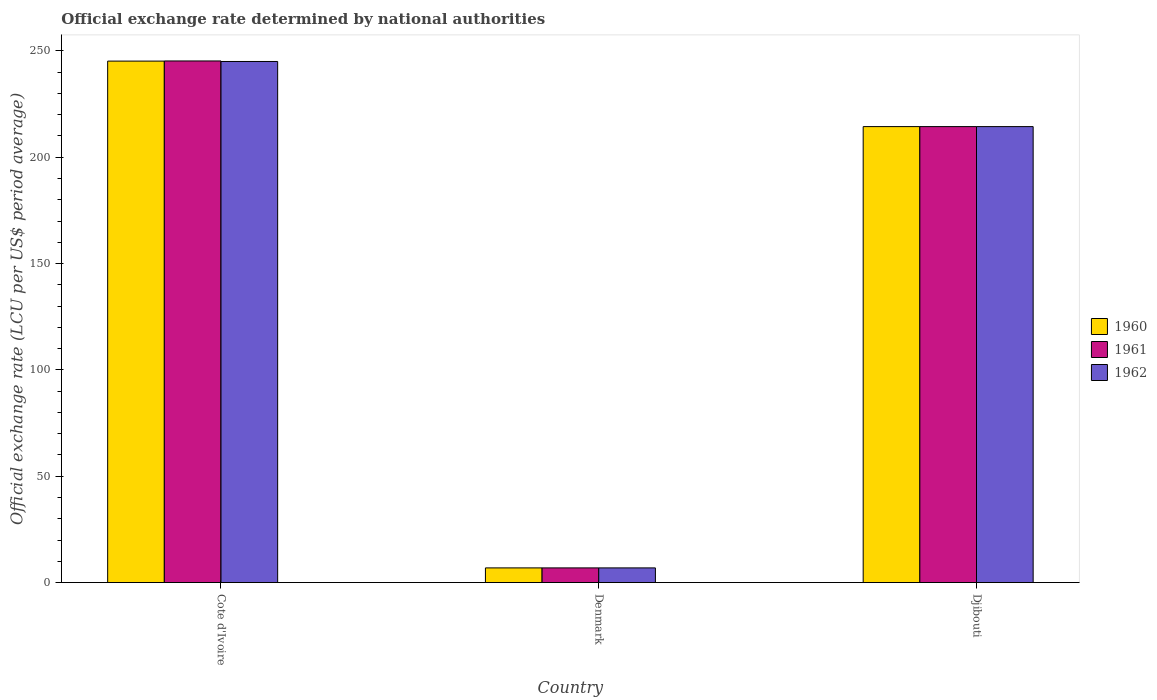How many different coloured bars are there?
Keep it short and to the point. 3. How many groups of bars are there?
Ensure brevity in your answer.  3. Are the number of bars per tick equal to the number of legend labels?
Give a very brief answer. Yes. Are the number of bars on each tick of the X-axis equal?
Offer a terse response. Yes. What is the label of the 3rd group of bars from the left?
Provide a succinct answer. Djibouti. In how many cases, is the number of bars for a given country not equal to the number of legend labels?
Your answer should be compact. 0. What is the official exchange rate in 1962 in Denmark?
Your answer should be compact. 6.91. Across all countries, what is the maximum official exchange rate in 1961?
Give a very brief answer. 245.26. Across all countries, what is the minimum official exchange rate in 1960?
Your answer should be very brief. 6.91. In which country was the official exchange rate in 1962 maximum?
Give a very brief answer. Cote d'Ivoire. What is the total official exchange rate in 1960 in the graph?
Provide a short and direct response. 466.49. What is the difference between the official exchange rate in 1960 in Cote d'Ivoire and that in Djibouti?
Your answer should be very brief. 30.8. What is the difference between the official exchange rate in 1961 in Djibouti and the official exchange rate in 1960 in Denmark?
Offer a terse response. 207.48. What is the average official exchange rate in 1960 per country?
Give a very brief answer. 155.5. What is the difference between the official exchange rate of/in 1960 and official exchange rate of/in 1961 in Djibouti?
Offer a terse response. 0. In how many countries, is the official exchange rate in 1961 greater than 130 LCU?
Provide a short and direct response. 2. What is the ratio of the official exchange rate in 1962 in Cote d'Ivoire to that in Djibouti?
Give a very brief answer. 1.14. What is the difference between the highest and the second highest official exchange rate in 1960?
Your response must be concise. 30.8. What is the difference between the highest and the lowest official exchange rate in 1960?
Ensure brevity in your answer.  238.29. Is the sum of the official exchange rate in 1960 in Denmark and Djibouti greater than the maximum official exchange rate in 1962 across all countries?
Make the answer very short. No. What does the 1st bar from the right in Djibouti represents?
Offer a very short reply. 1962. How many bars are there?
Your response must be concise. 9. What is the difference between two consecutive major ticks on the Y-axis?
Ensure brevity in your answer.  50. Does the graph contain any zero values?
Ensure brevity in your answer.  No. Where does the legend appear in the graph?
Keep it short and to the point. Center right. What is the title of the graph?
Provide a succinct answer. Official exchange rate determined by national authorities. What is the label or title of the Y-axis?
Provide a short and direct response. Official exchange rate (LCU per US$ period average). What is the Official exchange rate (LCU per US$ period average) of 1960 in Cote d'Ivoire?
Your answer should be compact. 245.2. What is the Official exchange rate (LCU per US$ period average) of 1961 in Cote d'Ivoire?
Make the answer very short. 245.26. What is the Official exchange rate (LCU per US$ period average) in 1962 in Cote d'Ivoire?
Offer a terse response. 245.01. What is the Official exchange rate (LCU per US$ period average) of 1960 in Denmark?
Keep it short and to the point. 6.91. What is the Official exchange rate (LCU per US$ period average) in 1961 in Denmark?
Ensure brevity in your answer.  6.91. What is the Official exchange rate (LCU per US$ period average) in 1962 in Denmark?
Your answer should be compact. 6.91. What is the Official exchange rate (LCU per US$ period average) of 1960 in Djibouti?
Give a very brief answer. 214.39. What is the Official exchange rate (LCU per US$ period average) in 1961 in Djibouti?
Your response must be concise. 214.39. What is the Official exchange rate (LCU per US$ period average) of 1962 in Djibouti?
Provide a short and direct response. 214.39. Across all countries, what is the maximum Official exchange rate (LCU per US$ period average) of 1960?
Make the answer very short. 245.2. Across all countries, what is the maximum Official exchange rate (LCU per US$ period average) of 1961?
Offer a very short reply. 245.26. Across all countries, what is the maximum Official exchange rate (LCU per US$ period average) of 1962?
Provide a short and direct response. 245.01. Across all countries, what is the minimum Official exchange rate (LCU per US$ period average) in 1960?
Offer a very short reply. 6.91. Across all countries, what is the minimum Official exchange rate (LCU per US$ period average) of 1961?
Provide a succinct answer. 6.91. Across all countries, what is the minimum Official exchange rate (LCU per US$ period average) in 1962?
Your answer should be compact. 6.91. What is the total Official exchange rate (LCU per US$ period average) of 1960 in the graph?
Make the answer very short. 466.49. What is the total Official exchange rate (LCU per US$ period average) in 1961 in the graph?
Provide a succinct answer. 466.56. What is the total Official exchange rate (LCU per US$ period average) of 1962 in the graph?
Provide a succinct answer. 466.31. What is the difference between the Official exchange rate (LCU per US$ period average) of 1960 in Cote d'Ivoire and that in Denmark?
Your response must be concise. 238.29. What is the difference between the Official exchange rate (LCU per US$ period average) of 1961 in Cote d'Ivoire and that in Denmark?
Your answer should be compact. 238.35. What is the difference between the Official exchange rate (LCU per US$ period average) of 1962 in Cote d'Ivoire and that in Denmark?
Your response must be concise. 238.11. What is the difference between the Official exchange rate (LCU per US$ period average) of 1960 in Cote d'Ivoire and that in Djibouti?
Give a very brief answer. 30.8. What is the difference between the Official exchange rate (LCU per US$ period average) of 1961 in Cote d'Ivoire and that in Djibouti?
Give a very brief answer. 30.87. What is the difference between the Official exchange rate (LCU per US$ period average) in 1962 in Cote d'Ivoire and that in Djibouti?
Give a very brief answer. 30.62. What is the difference between the Official exchange rate (LCU per US$ period average) of 1960 in Denmark and that in Djibouti?
Keep it short and to the point. -207.48. What is the difference between the Official exchange rate (LCU per US$ period average) of 1961 in Denmark and that in Djibouti?
Ensure brevity in your answer.  -207.48. What is the difference between the Official exchange rate (LCU per US$ period average) of 1962 in Denmark and that in Djibouti?
Your response must be concise. -207.48. What is the difference between the Official exchange rate (LCU per US$ period average) of 1960 in Cote d'Ivoire and the Official exchange rate (LCU per US$ period average) of 1961 in Denmark?
Make the answer very short. 238.29. What is the difference between the Official exchange rate (LCU per US$ period average) in 1960 in Cote d'Ivoire and the Official exchange rate (LCU per US$ period average) in 1962 in Denmark?
Keep it short and to the point. 238.29. What is the difference between the Official exchange rate (LCU per US$ period average) of 1961 in Cote d'Ivoire and the Official exchange rate (LCU per US$ period average) of 1962 in Denmark?
Ensure brevity in your answer.  238.35. What is the difference between the Official exchange rate (LCU per US$ period average) of 1960 in Cote d'Ivoire and the Official exchange rate (LCU per US$ period average) of 1961 in Djibouti?
Offer a very short reply. 30.8. What is the difference between the Official exchange rate (LCU per US$ period average) of 1960 in Cote d'Ivoire and the Official exchange rate (LCU per US$ period average) of 1962 in Djibouti?
Give a very brief answer. 30.8. What is the difference between the Official exchange rate (LCU per US$ period average) in 1961 in Cote d'Ivoire and the Official exchange rate (LCU per US$ period average) in 1962 in Djibouti?
Make the answer very short. 30.87. What is the difference between the Official exchange rate (LCU per US$ period average) of 1960 in Denmark and the Official exchange rate (LCU per US$ period average) of 1961 in Djibouti?
Ensure brevity in your answer.  -207.48. What is the difference between the Official exchange rate (LCU per US$ period average) in 1960 in Denmark and the Official exchange rate (LCU per US$ period average) in 1962 in Djibouti?
Offer a very short reply. -207.48. What is the difference between the Official exchange rate (LCU per US$ period average) in 1961 in Denmark and the Official exchange rate (LCU per US$ period average) in 1962 in Djibouti?
Your response must be concise. -207.48. What is the average Official exchange rate (LCU per US$ period average) of 1960 per country?
Your answer should be very brief. 155.5. What is the average Official exchange rate (LCU per US$ period average) of 1961 per country?
Ensure brevity in your answer.  155.52. What is the average Official exchange rate (LCU per US$ period average) of 1962 per country?
Provide a succinct answer. 155.44. What is the difference between the Official exchange rate (LCU per US$ period average) in 1960 and Official exchange rate (LCU per US$ period average) in 1961 in Cote d'Ivoire?
Ensure brevity in your answer.  -0.07. What is the difference between the Official exchange rate (LCU per US$ period average) of 1960 and Official exchange rate (LCU per US$ period average) of 1962 in Cote d'Ivoire?
Provide a succinct answer. 0.18. What is the difference between the Official exchange rate (LCU per US$ period average) in 1961 and Official exchange rate (LCU per US$ period average) in 1962 in Cote d'Ivoire?
Your answer should be compact. 0.25. What is the difference between the Official exchange rate (LCU per US$ period average) in 1960 and Official exchange rate (LCU per US$ period average) in 1962 in Denmark?
Ensure brevity in your answer.  0. What is the ratio of the Official exchange rate (LCU per US$ period average) in 1960 in Cote d'Ivoire to that in Denmark?
Offer a very short reply. 35.5. What is the ratio of the Official exchange rate (LCU per US$ period average) in 1961 in Cote d'Ivoire to that in Denmark?
Your answer should be very brief. 35.51. What is the ratio of the Official exchange rate (LCU per US$ period average) of 1962 in Cote d'Ivoire to that in Denmark?
Your answer should be compact. 35.47. What is the ratio of the Official exchange rate (LCU per US$ period average) of 1960 in Cote d'Ivoire to that in Djibouti?
Keep it short and to the point. 1.14. What is the ratio of the Official exchange rate (LCU per US$ period average) in 1961 in Cote d'Ivoire to that in Djibouti?
Provide a short and direct response. 1.14. What is the ratio of the Official exchange rate (LCU per US$ period average) of 1962 in Cote d'Ivoire to that in Djibouti?
Your answer should be compact. 1.14. What is the ratio of the Official exchange rate (LCU per US$ period average) in 1960 in Denmark to that in Djibouti?
Ensure brevity in your answer.  0.03. What is the ratio of the Official exchange rate (LCU per US$ period average) of 1961 in Denmark to that in Djibouti?
Your response must be concise. 0.03. What is the ratio of the Official exchange rate (LCU per US$ period average) in 1962 in Denmark to that in Djibouti?
Ensure brevity in your answer.  0.03. What is the difference between the highest and the second highest Official exchange rate (LCU per US$ period average) in 1960?
Keep it short and to the point. 30.8. What is the difference between the highest and the second highest Official exchange rate (LCU per US$ period average) in 1961?
Keep it short and to the point. 30.87. What is the difference between the highest and the second highest Official exchange rate (LCU per US$ period average) of 1962?
Make the answer very short. 30.62. What is the difference between the highest and the lowest Official exchange rate (LCU per US$ period average) in 1960?
Offer a very short reply. 238.29. What is the difference between the highest and the lowest Official exchange rate (LCU per US$ period average) of 1961?
Offer a very short reply. 238.35. What is the difference between the highest and the lowest Official exchange rate (LCU per US$ period average) in 1962?
Your answer should be compact. 238.11. 